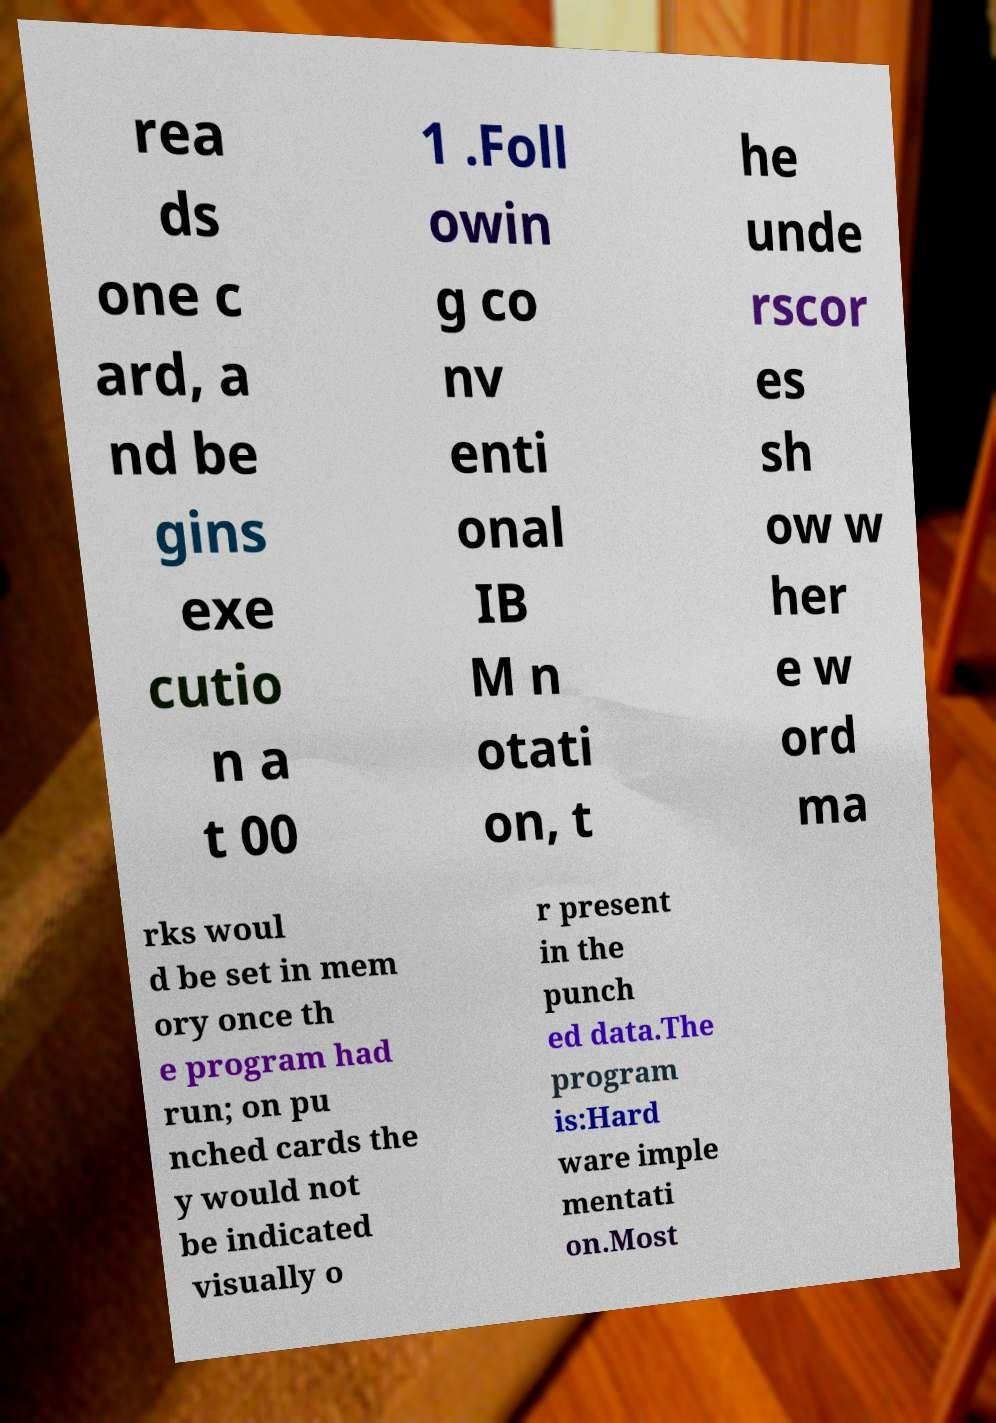Can you accurately transcribe the text from the provided image for me? rea ds one c ard, a nd be gins exe cutio n a t 00 1 .Foll owin g co nv enti onal IB M n otati on, t he unde rscor es sh ow w her e w ord ma rks woul d be set in mem ory once th e program had run; on pu nched cards the y would not be indicated visually o r present in the punch ed data.The program is:Hard ware imple mentati on.Most 